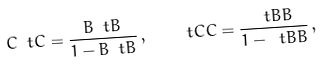<formula> <loc_0><loc_0><loc_500><loc_500>C \ t C = \frac { B \ t B } { 1 - B \ t B } \, , \quad \ t C C = \frac { \ t B B } { 1 - \ t B B } \, ,</formula> 